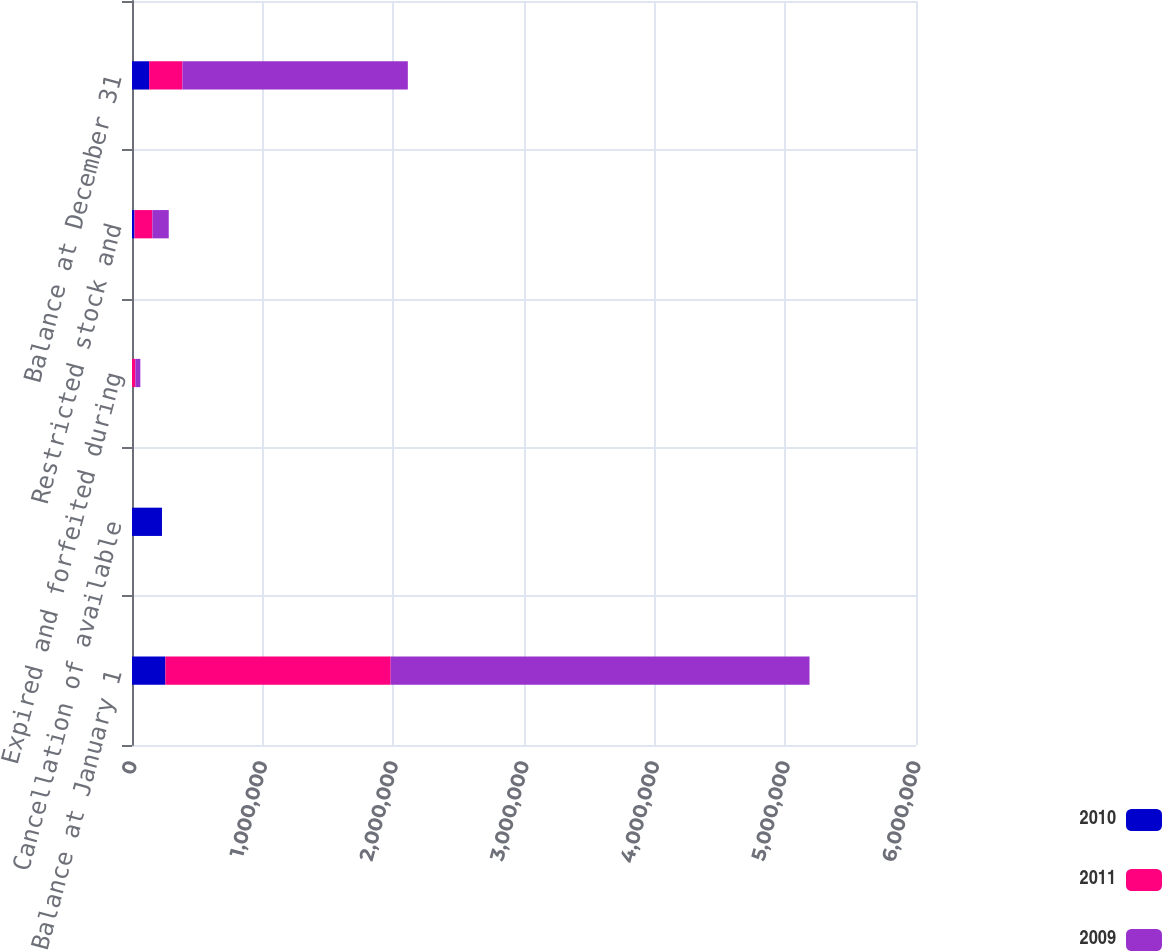<chart> <loc_0><loc_0><loc_500><loc_500><stacked_bar_chart><ecel><fcel>Balance at January 1<fcel>Cancellation of available<fcel>Expired and forfeited during<fcel>Restricted stock and<fcel>Balance at December 31<nl><fcel>2010<fcel>255263<fcel>229333<fcel>0<fcel>19017<fcel>131132<nl><fcel>2011<fcel>1.72454e+06<fcel>0<fcel>26269<fcel>137371<fcel>255263<nl><fcel>2009<fcel>3.20521e+06<fcel>0<fcel>37500<fcel>124894<fcel>1.72454e+06<nl></chart> 